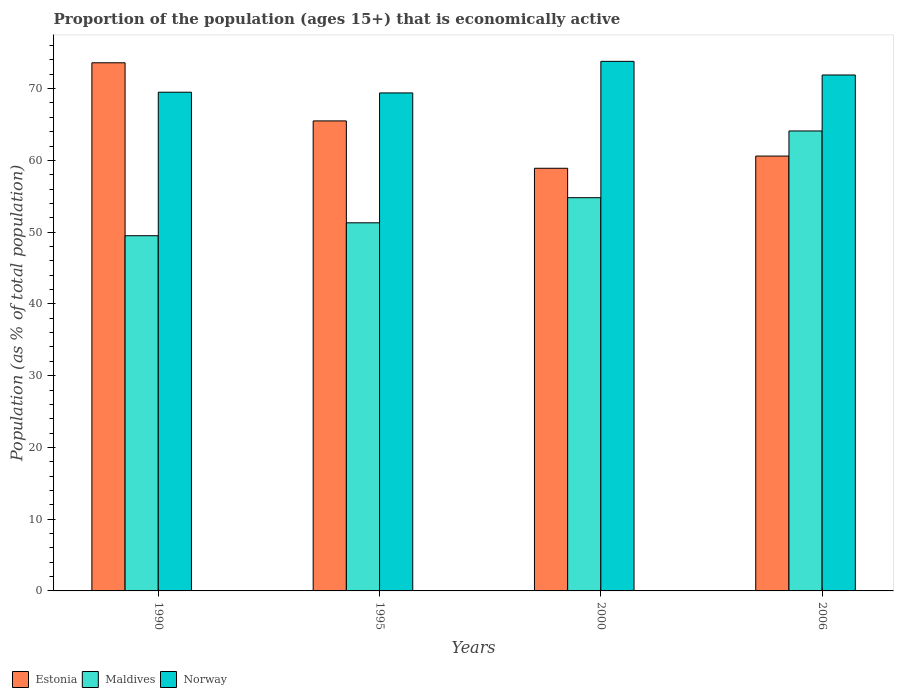How many different coloured bars are there?
Make the answer very short. 3. How many groups of bars are there?
Give a very brief answer. 4. In how many cases, is the number of bars for a given year not equal to the number of legend labels?
Make the answer very short. 0. What is the proportion of the population that is economically active in Estonia in 2000?
Ensure brevity in your answer.  58.9. Across all years, what is the maximum proportion of the population that is economically active in Maldives?
Your answer should be compact. 64.1. Across all years, what is the minimum proportion of the population that is economically active in Norway?
Your answer should be compact. 69.4. What is the total proportion of the population that is economically active in Norway in the graph?
Keep it short and to the point. 284.6. What is the difference between the proportion of the population that is economically active in Estonia in 1995 and that in 2006?
Ensure brevity in your answer.  4.9. What is the difference between the proportion of the population that is economically active in Norway in 2006 and the proportion of the population that is economically active in Estonia in 1995?
Your answer should be very brief. 6.4. What is the average proportion of the population that is economically active in Norway per year?
Offer a very short reply. 71.15. In the year 1995, what is the difference between the proportion of the population that is economically active in Norway and proportion of the population that is economically active in Estonia?
Ensure brevity in your answer.  3.9. In how many years, is the proportion of the population that is economically active in Norway greater than 14 %?
Keep it short and to the point. 4. What is the ratio of the proportion of the population that is economically active in Maldives in 2000 to that in 2006?
Give a very brief answer. 0.85. Is the proportion of the population that is economically active in Norway in 1995 less than that in 2006?
Provide a succinct answer. Yes. Is the difference between the proportion of the population that is economically active in Norway in 1990 and 2006 greater than the difference between the proportion of the population that is economically active in Estonia in 1990 and 2006?
Keep it short and to the point. No. What is the difference between the highest and the second highest proportion of the population that is economically active in Maldives?
Keep it short and to the point. 9.3. What is the difference between the highest and the lowest proportion of the population that is economically active in Norway?
Provide a succinct answer. 4.4. What does the 1st bar from the left in 1995 represents?
Keep it short and to the point. Estonia. What does the 1st bar from the right in 2006 represents?
Provide a succinct answer. Norway. Is it the case that in every year, the sum of the proportion of the population that is economically active in Norway and proportion of the population that is economically active in Maldives is greater than the proportion of the population that is economically active in Estonia?
Provide a short and direct response. Yes. Are all the bars in the graph horizontal?
Your answer should be very brief. No. How many years are there in the graph?
Keep it short and to the point. 4. What is the difference between two consecutive major ticks on the Y-axis?
Provide a short and direct response. 10. Does the graph contain any zero values?
Ensure brevity in your answer.  No. Where does the legend appear in the graph?
Your answer should be compact. Bottom left. What is the title of the graph?
Give a very brief answer. Proportion of the population (ages 15+) that is economically active. Does "Benin" appear as one of the legend labels in the graph?
Offer a very short reply. No. What is the label or title of the X-axis?
Make the answer very short. Years. What is the label or title of the Y-axis?
Make the answer very short. Population (as % of total population). What is the Population (as % of total population) of Estonia in 1990?
Ensure brevity in your answer.  73.6. What is the Population (as % of total population) of Maldives in 1990?
Your answer should be compact. 49.5. What is the Population (as % of total population) in Norway in 1990?
Your answer should be very brief. 69.5. What is the Population (as % of total population) of Estonia in 1995?
Provide a short and direct response. 65.5. What is the Population (as % of total population) of Maldives in 1995?
Offer a very short reply. 51.3. What is the Population (as % of total population) in Norway in 1995?
Keep it short and to the point. 69.4. What is the Population (as % of total population) of Estonia in 2000?
Your response must be concise. 58.9. What is the Population (as % of total population) in Maldives in 2000?
Make the answer very short. 54.8. What is the Population (as % of total population) in Norway in 2000?
Keep it short and to the point. 73.8. What is the Population (as % of total population) of Estonia in 2006?
Provide a succinct answer. 60.6. What is the Population (as % of total population) of Maldives in 2006?
Offer a very short reply. 64.1. What is the Population (as % of total population) in Norway in 2006?
Provide a succinct answer. 71.9. Across all years, what is the maximum Population (as % of total population) in Estonia?
Your answer should be compact. 73.6. Across all years, what is the maximum Population (as % of total population) of Maldives?
Keep it short and to the point. 64.1. Across all years, what is the maximum Population (as % of total population) in Norway?
Ensure brevity in your answer.  73.8. Across all years, what is the minimum Population (as % of total population) of Estonia?
Provide a succinct answer. 58.9. Across all years, what is the minimum Population (as % of total population) in Maldives?
Your response must be concise. 49.5. Across all years, what is the minimum Population (as % of total population) in Norway?
Your answer should be very brief. 69.4. What is the total Population (as % of total population) of Estonia in the graph?
Ensure brevity in your answer.  258.6. What is the total Population (as % of total population) in Maldives in the graph?
Offer a very short reply. 219.7. What is the total Population (as % of total population) in Norway in the graph?
Your answer should be compact. 284.6. What is the difference between the Population (as % of total population) in Maldives in 1990 and that in 1995?
Give a very brief answer. -1.8. What is the difference between the Population (as % of total population) of Norway in 1990 and that in 1995?
Offer a terse response. 0.1. What is the difference between the Population (as % of total population) in Estonia in 1990 and that in 2000?
Provide a succinct answer. 14.7. What is the difference between the Population (as % of total population) in Norway in 1990 and that in 2000?
Make the answer very short. -4.3. What is the difference between the Population (as % of total population) in Maldives in 1990 and that in 2006?
Give a very brief answer. -14.6. What is the difference between the Population (as % of total population) of Norway in 1990 and that in 2006?
Offer a very short reply. -2.4. What is the difference between the Population (as % of total population) of Maldives in 1995 and that in 2000?
Offer a terse response. -3.5. What is the difference between the Population (as % of total population) in Norway in 1995 and that in 2000?
Provide a succinct answer. -4.4. What is the difference between the Population (as % of total population) in Estonia in 1995 and that in 2006?
Ensure brevity in your answer.  4.9. What is the difference between the Population (as % of total population) in Maldives in 1995 and that in 2006?
Your answer should be very brief. -12.8. What is the difference between the Population (as % of total population) of Estonia in 1990 and the Population (as % of total population) of Maldives in 1995?
Give a very brief answer. 22.3. What is the difference between the Population (as % of total population) in Estonia in 1990 and the Population (as % of total population) in Norway in 1995?
Your response must be concise. 4.2. What is the difference between the Population (as % of total population) in Maldives in 1990 and the Population (as % of total population) in Norway in 1995?
Ensure brevity in your answer.  -19.9. What is the difference between the Population (as % of total population) in Maldives in 1990 and the Population (as % of total population) in Norway in 2000?
Your response must be concise. -24.3. What is the difference between the Population (as % of total population) in Estonia in 1990 and the Population (as % of total population) in Norway in 2006?
Keep it short and to the point. 1.7. What is the difference between the Population (as % of total population) in Maldives in 1990 and the Population (as % of total population) in Norway in 2006?
Make the answer very short. -22.4. What is the difference between the Population (as % of total population) in Estonia in 1995 and the Population (as % of total population) in Maldives in 2000?
Provide a short and direct response. 10.7. What is the difference between the Population (as % of total population) of Maldives in 1995 and the Population (as % of total population) of Norway in 2000?
Keep it short and to the point. -22.5. What is the difference between the Population (as % of total population) of Estonia in 1995 and the Population (as % of total population) of Maldives in 2006?
Your answer should be very brief. 1.4. What is the difference between the Population (as % of total population) in Maldives in 1995 and the Population (as % of total population) in Norway in 2006?
Offer a very short reply. -20.6. What is the difference between the Population (as % of total population) in Estonia in 2000 and the Population (as % of total population) in Norway in 2006?
Offer a very short reply. -13. What is the difference between the Population (as % of total population) of Maldives in 2000 and the Population (as % of total population) of Norway in 2006?
Keep it short and to the point. -17.1. What is the average Population (as % of total population) of Estonia per year?
Your answer should be very brief. 64.65. What is the average Population (as % of total population) in Maldives per year?
Offer a very short reply. 54.92. What is the average Population (as % of total population) of Norway per year?
Give a very brief answer. 71.15. In the year 1990, what is the difference between the Population (as % of total population) in Estonia and Population (as % of total population) in Maldives?
Ensure brevity in your answer.  24.1. In the year 1990, what is the difference between the Population (as % of total population) in Maldives and Population (as % of total population) in Norway?
Offer a very short reply. -20. In the year 1995, what is the difference between the Population (as % of total population) of Estonia and Population (as % of total population) of Maldives?
Offer a terse response. 14.2. In the year 1995, what is the difference between the Population (as % of total population) in Estonia and Population (as % of total population) in Norway?
Your response must be concise. -3.9. In the year 1995, what is the difference between the Population (as % of total population) in Maldives and Population (as % of total population) in Norway?
Your answer should be compact. -18.1. In the year 2000, what is the difference between the Population (as % of total population) of Estonia and Population (as % of total population) of Norway?
Your response must be concise. -14.9. In the year 2000, what is the difference between the Population (as % of total population) in Maldives and Population (as % of total population) in Norway?
Give a very brief answer. -19. In the year 2006, what is the difference between the Population (as % of total population) in Estonia and Population (as % of total population) in Norway?
Your response must be concise. -11.3. In the year 2006, what is the difference between the Population (as % of total population) of Maldives and Population (as % of total population) of Norway?
Provide a short and direct response. -7.8. What is the ratio of the Population (as % of total population) of Estonia in 1990 to that in 1995?
Your answer should be compact. 1.12. What is the ratio of the Population (as % of total population) in Maldives in 1990 to that in 1995?
Your response must be concise. 0.96. What is the ratio of the Population (as % of total population) in Norway in 1990 to that in 1995?
Ensure brevity in your answer.  1. What is the ratio of the Population (as % of total population) in Estonia in 1990 to that in 2000?
Make the answer very short. 1.25. What is the ratio of the Population (as % of total population) of Maldives in 1990 to that in 2000?
Your answer should be very brief. 0.9. What is the ratio of the Population (as % of total population) of Norway in 1990 to that in 2000?
Your answer should be compact. 0.94. What is the ratio of the Population (as % of total population) of Estonia in 1990 to that in 2006?
Ensure brevity in your answer.  1.21. What is the ratio of the Population (as % of total population) in Maldives in 1990 to that in 2006?
Your answer should be compact. 0.77. What is the ratio of the Population (as % of total population) of Norway in 1990 to that in 2006?
Give a very brief answer. 0.97. What is the ratio of the Population (as % of total population) in Estonia in 1995 to that in 2000?
Provide a short and direct response. 1.11. What is the ratio of the Population (as % of total population) in Maldives in 1995 to that in 2000?
Make the answer very short. 0.94. What is the ratio of the Population (as % of total population) in Norway in 1995 to that in 2000?
Offer a very short reply. 0.94. What is the ratio of the Population (as % of total population) in Estonia in 1995 to that in 2006?
Your response must be concise. 1.08. What is the ratio of the Population (as % of total population) in Maldives in 1995 to that in 2006?
Your answer should be compact. 0.8. What is the ratio of the Population (as % of total population) of Norway in 1995 to that in 2006?
Offer a very short reply. 0.97. What is the ratio of the Population (as % of total population) of Estonia in 2000 to that in 2006?
Give a very brief answer. 0.97. What is the ratio of the Population (as % of total population) in Maldives in 2000 to that in 2006?
Offer a terse response. 0.85. What is the ratio of the Population (as % of total population) of Norway in 2000 to that in 2006?
Make the answer very short. 1.03. 